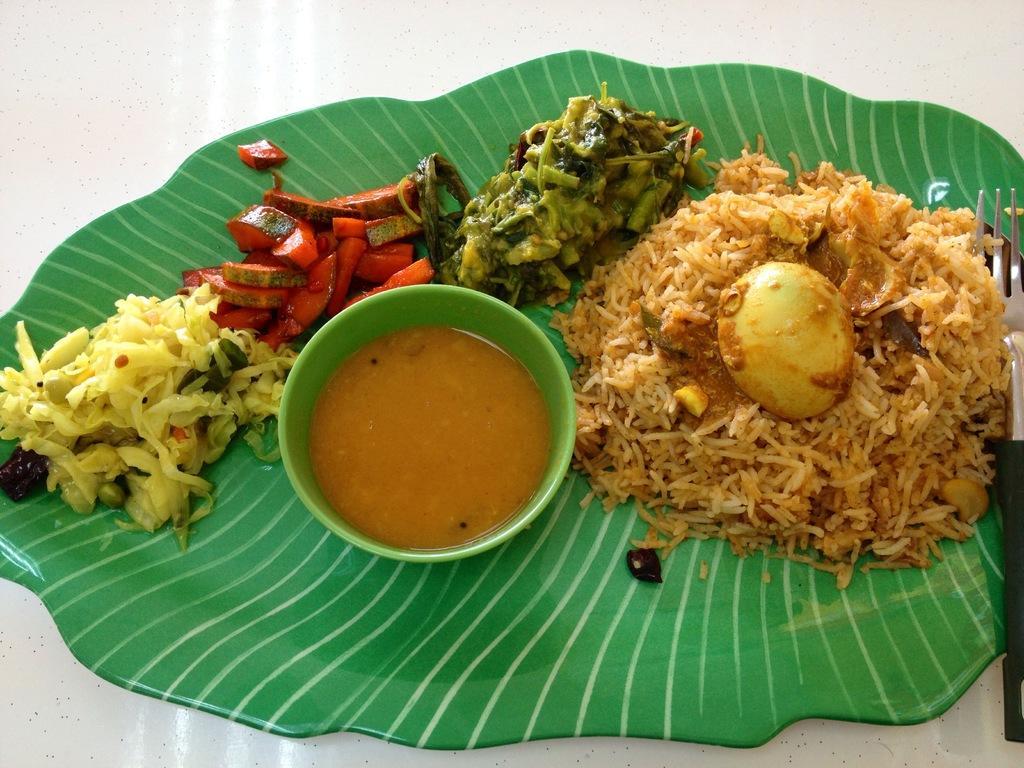Describe this image in one or two sentences. In this picture I can see food items, fork and a bowl with a liquid in it, on the plate, on an object. 